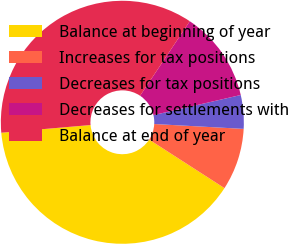Convert chart. <chart><loc_0><loc_0><loc_500><loc_500><pie_chart><fcel>Balance at beginning of year<fcel>Increases for tax positions<fcel>Decreases for tax positions<fcel>Decreases for settlements with<fcel>Balance at end of year<nl><fcel>39.52%<fcel>8.25%<fcel>4.47%<fcel>12.03%<fcel>35.74%<nl></chart> 